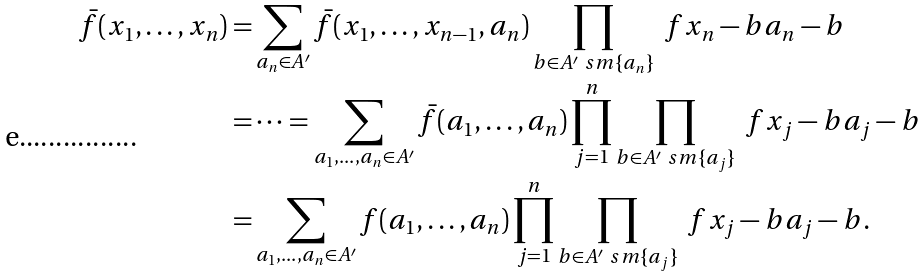Convert formula to latex. <formula><loc_0><loc_0><loc_500><loc_500>\bar { f } ( x _ { 1 } , \dots , x _ { n } ) = & \sum _ { a _ { n } \in A ^ { \prime } } \bar { f } ( x _ { 1 } , \dots , x _ { n - 1 } , a _ { n } ) \prod _ { b \in A ^ { \prime } \ s m \{ a _ { n } \} } \ f { x _ { n } - b } { a _ { n } - b } \\ = & \cdots = \sum _ { a _ { 1 } , \dots , a _ { n } \in A ^ { \prime } } \bar { f } ( a _ { 1 } , \dots , a _ { n } ) \prod _ { j = 1 } ^ { n } \prod _ { b \in A ^ { \prime } \ s m \{ a _ { j } \} } \ f { x _ { j } - b } { a _ { j } - b } \\ = & \sum _ { a _ { 1 } , \dots , a _ { n } \in A ^ { \prime } } f ( a _ { 1 } , \dots , a _ { n } ) \prod _ { j = 1 } ^ { n } \prod _ { b \in A ^ { \prime } \ s m \{ a _ { j } \} } \ f { x _ { j } - b } { a _ { j } - b } .</formula> 